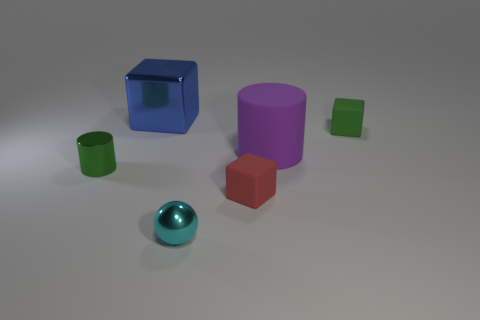The tiny thing that is the same color as the small cylinder is what shape?
Provide a succinct answer. Cube. There is a block that is the same color as the metal cylinder; what is its size?
Keep it short and to the point. Small. There is a block in front of the tiny object that is on the left side of the big blue metallic object; what is its material?
Your answer should be compact. Rubber. What shape is the small object that is behind the red object and to the right of the cyan shiny ball?
Ensure brevity in your answer.  Cube. The other thing that is the same shape as the large purple matte thing is what size?
Offer a terse response. Small. Is the number of cyan shiny balls to the right of the big purple thing less than the number of cyan balls?
Provide a succinct answer. Yes. What is the size of the cylinder that is behind the tiny green metal object?
Your response must be concise. Large. What is the color of the large thing that is the same shape as the tiny green metallic thing?
Offer a terse response. Purple. What number of tiny shiny spheres have the same color as the matte cylinder?
Give a very brief answer. 0. Is there anything else that is the same shape as the purple rubber object?
Your response must be concise. Yes. 